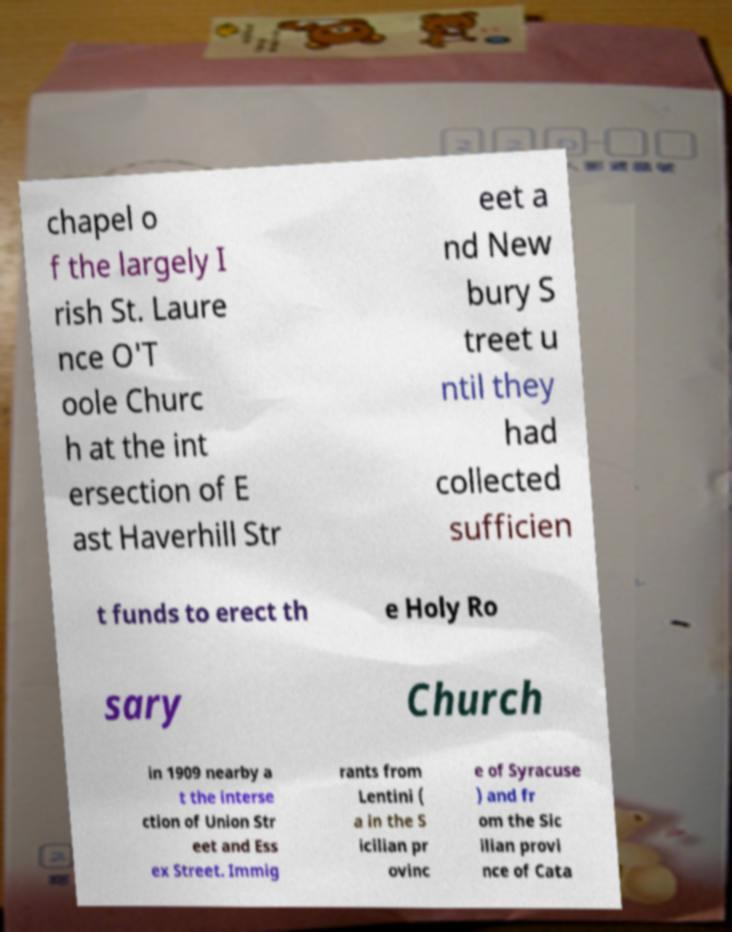Can you accurately transcribe the text from the provided image for me? chapel o f the largely I rish St. Laure nce O'T oole Churc h at the int ersection of E ast Haverhill Str eet a nd New bury S treet u ntil they had collected sufficien t funds to erect th e Holy Ro sary Church in 1909 nearby a t the interse ction of Union Str eet and Ess ex Street. Immig rants from Lentini ( a in the S icilian pr ovinc e of Syracuse ) and fr om the Sic ilian provi nce of Cata 